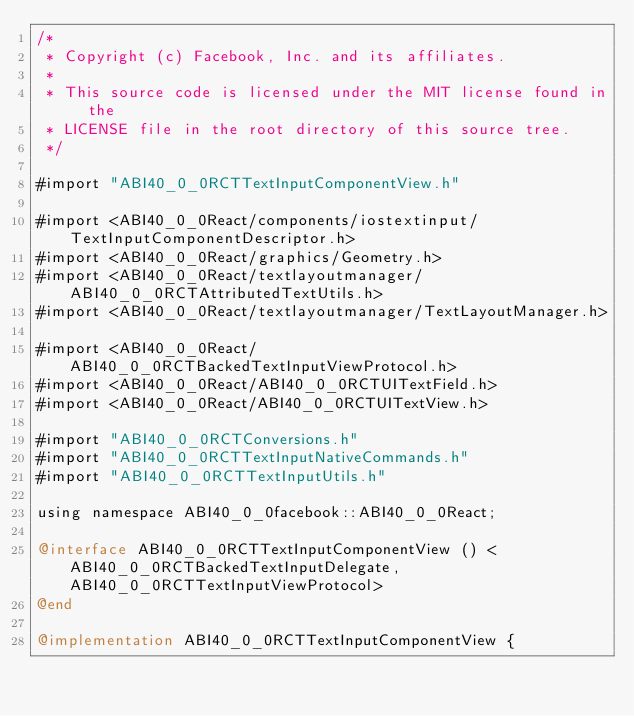<code> <loc_0><loc_0><loc_500><loc_500><_ObjectiveC_>/*
 * Copyright (c) Facebook, Inc. and its affiliates.
 *
 * This source code is licensed under the MIT license found in the
 * LICENSE file in the root directory of this source tree.
 */

#import "ABI40_0_0RCTTextInputComponentView.h"

#import <ABI40_0_0React/components/iostextinput/TextInputComponentDescriptor.h>
#import <ABI40_0_0React/graphics/Geometry.h>
#import <ABI40_0_0React/textlayoutmanager/ABI40_0_0RCTAttributedTextUtils.h>
#import <ABI40_0_0React/textlayoutmanager/TextLayoutManager.h>

#import <ABI40_0_0React/ABI40_0_0RCTBackedTextInputViewProtocol.h>
#import <ABI40_0_0React/ABI40_0_0RCTUITextField.h>
#import <ABI40_0_0React/ABI40_0_0RCTUITextView.h>

#import "ABI40_0_0RCTConversions.h"
#import "ABI40_0_0RCTTextInputNativeCommands.h"
#import "ABI40_0_0RCTTextInputUtils.h"

using namespace ABI40_0_0facebook::ABI40_0_0React;

@interface ABI40_0_0RCTTextInputComponentView () <ABI40_0_0RCTBackedTextInputDelegate, ABI40_0_0RCTTextInputViewProtocol>
@end

@implementation ABI40_0_0RCTTextInputComponentView {</code> 